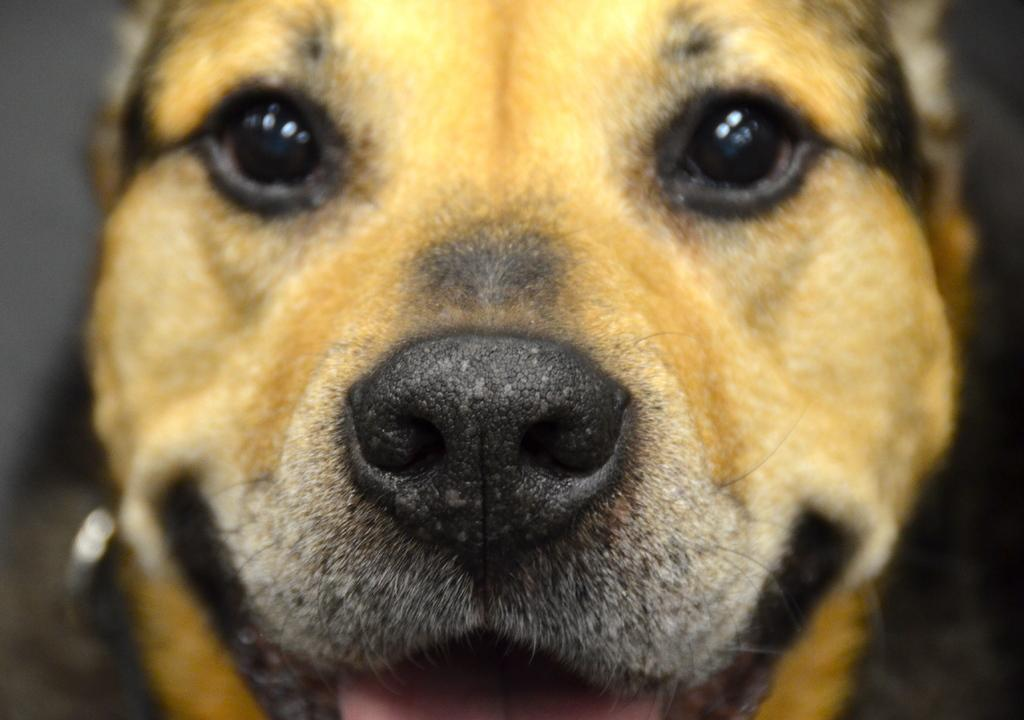What is the main subject of the image? The main subject of the image is a dog. Where is the dog located in the image? The dog is in the center of the image. What colors can be seen on the dog? The dog is brown and black in color. What type of business is being conducted in the image? There is no indication of a business or any business-related activity in the image, as it features a dog in the center. 